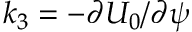<formula> <loc_0><loc_0><loc_500><loc_500>k _ { 3 } = - \partial U _ { 0 } / \partial \psi</formula> 